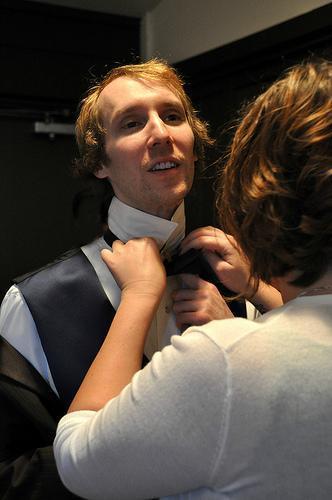How many people are in this photo?
Give a very brief answer. 2. How many hands are visible in this photo?
Give a very brief answer. 3. How many visible rows of teeth are visible in this photo?
Give a very brief answer. 1. 